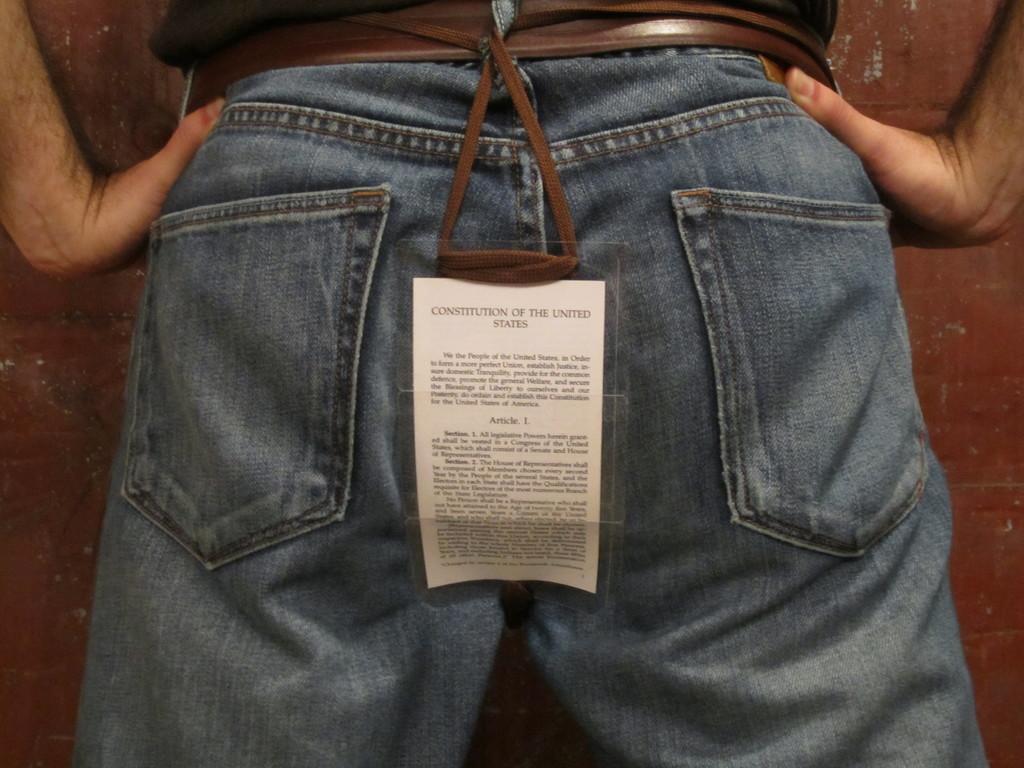Please provide a concise description of this image. In the center of the image we can see one banner and one person standing. On the banner, we can see some text. In the background there is a wall and a few other objects. 